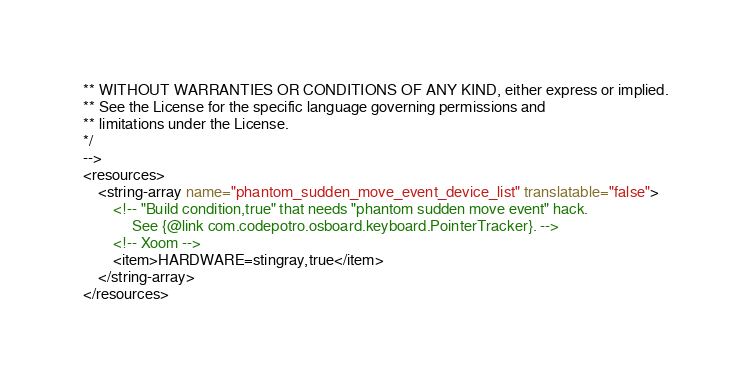Convert code to text. <code><loc_0><loc_0><loc_500><loc_500><_XML_>** WITHOUT WARRANTIES OR CONDITIONS OF ANY KIND, either express or implied.
** See the License for the specific language governing permissions and
** limitations under the License.
*/
-->
<resources>
    <string-array name="phantom_sudden_move_event_device_list" translatable="false">
        <!-- "Build condition,true" that needs "phantom sudden move event" hack.
             See {@link com.codepotro.osboard.keyboard.PointerTracker}. -->
        <!-- Xoom -->
        <item>HARDWARE=stingray,true</item>
    </string-array>
</resources>
</code> 